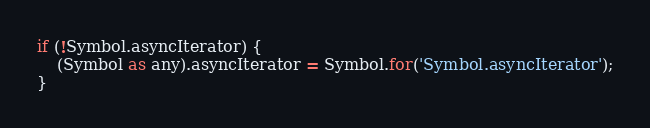<code> <loc_0><loc_0><loc_500><loc_500><_TypeScript_>if (!Symbol.asyncIterator) {
	(Symbol as any).asyncIterator = Symbol.for('Symbol.asyncIterator');
}
</code> 